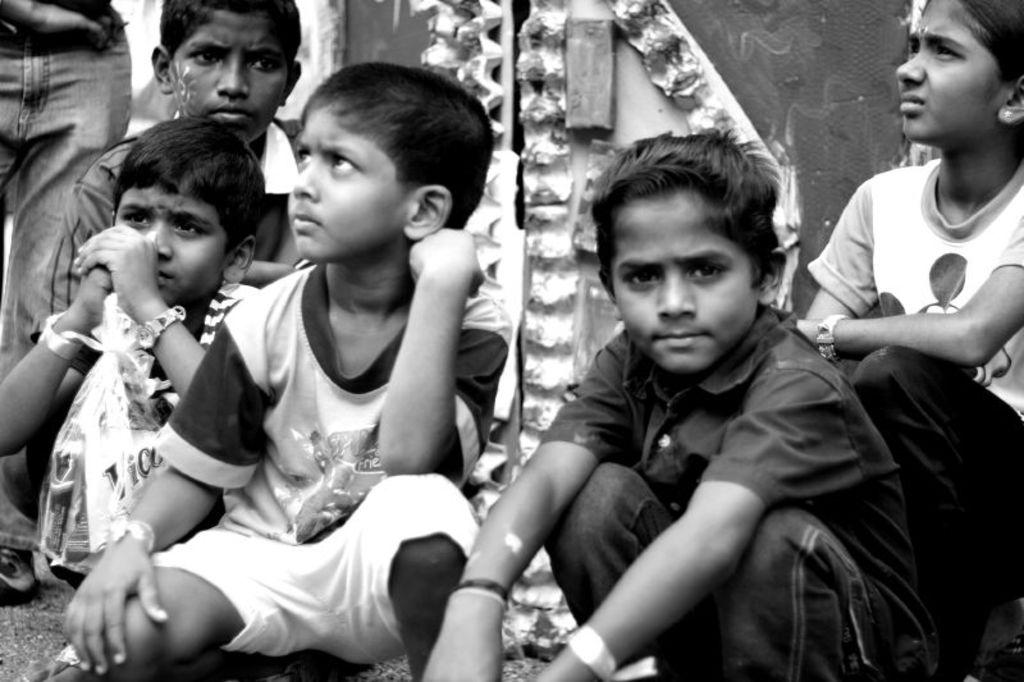What is the main subject of the image? The main subject of the image is the children in the center of the image. Can you describe the location of the children in the image? The children are in the center of the image. What can be seen in the background of the image? There is a door visible in the background of the image. What type of brush is being used by the children in the image? There is no brush present in the image; the children are not depicted using any tools or objects. 